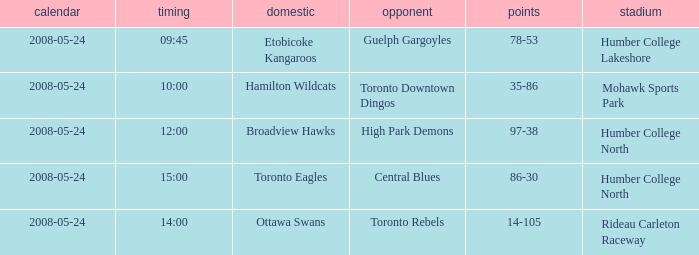On which date did the contest end in a 97-38 score? 2008-05-24. 